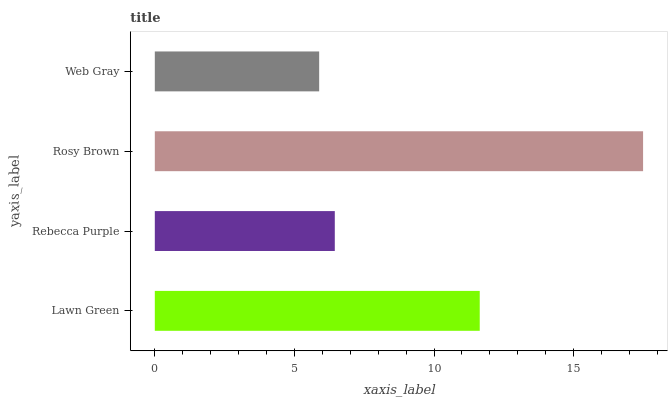Is Web Gray the minimum?
Answer yes or no. Yes. Is Rosy Brown the maximum?
Answer yes or no. Yes. Is Rebecca Purple the minimum?
Answer yes or no. No. Is Rebecca Purple the maximum?
Answer yes or no. No. Is Lawn Green greater than Rebecca Purple?
Answer yes or no. Yes. Is Rebecca Purple less than Lawn Green?
Answer yes or no. Yes. Is Rebecca Purple greater than Lawn Green?
Answer yes or no. No. Is Lawn Green less than Rebecca Purple?
Answer yes or no. No. Is Lawn Green the high median?
Answer yes or no. Yes. Is Rebecca Purple the low median?
Answer yes or no. Yes. Is Rebecca Purple the high median?
Answer yes or no. No. Is Rosy Brown the low median?
Answer yes or no. No. 